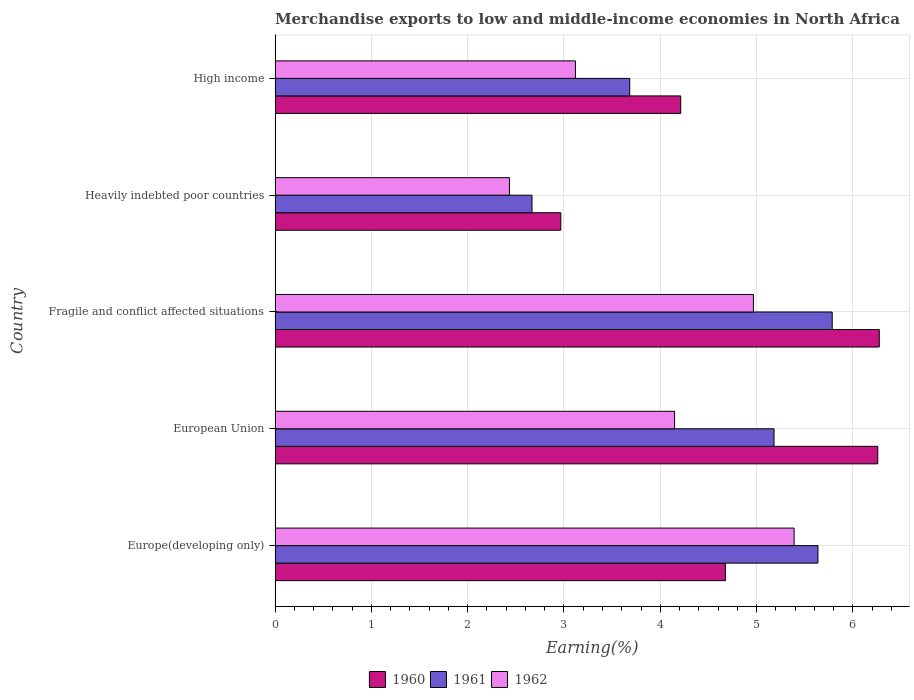How many different coloured bars are there?
Offer a terse response. 3. How many groups of bars are there?
Give a very brief answer. 5. Are the number of bars per tick equal to the number of legend labels?
Provide a short and direct response. Yes. Are the number of bars on each tick of the Y-axis equal?
Provide a short and direct response. Yes. How many bars are there on the 4th tick from the top?
Provide a short and direct response. 3. How many bars are there on the 3rd tick from the bottom?
Your answer should be compact. 3. What is the label of the 2nd group of bars from the top?
Provide a succinct answer. Heavily indebted poor countries. In how many cases, is the number of bars for a given country not equal to the number of legend labels?
Your response must be concise. 0. What is the percentage of amount earned from merchandise exports in 1962 in Europe(developing only)?
Make the answer very short. 5.39. Across all countries, what is the maximum percentage of amount earned from merchandise exports in 1961?
Make the answer very short. 5.79. Across all countries, what is the minimum percentage of amount earned from merchandise exports in 1962?
Your answer should be compact. 2.43. In which country was the percentage of amount earned from merchandise exports in 1962 maximum?
Ensure brevity in your answer.  Europe(developing only). In which country was the percentage of amount earned from merchandise exports in 1962 minimum?
Give a very brief answer. Heavily indebted poor countries. What is the total percentage of amount earned from merchandise exports in 1960 in the graph?
Offer a very short reply. 24.39. What is the difference between the percentage of amount earned from merchandise exports in 1962 in European Union and that in Fragile and conflict affected situations?
Provide a short and direct response. -0.82. What is the difference between the percentage of amount earned from merchandise exports in 1961 in Heavily indebted poor countries and the percentage of amount earned from merchandise exports in 1960 in European Union?
Offer a very short reply. -3.59. What is the average percentage of amount earned from merchandise exports in 1961 per country?
Keep it short and to the point. 4.59. What is the difference between the percentage of amount earned from merchandise exports in 1961 and percentage of amount earned from merchandise exports in 1962 in Fragile and conflict affected situations?
Provide a short and direct response. 0.82. In how many countries, is the percentage of amount earned from merchandise exports in 1962 greater than 1.8 %?
Your response must be concise. 5. What is the ratio of the percentage of amount earned from merchandise exports in 1961 in Europe(developing only) to that in High income?
Your answer should be very brief. 1.53. Is the percentage of amount earned from merchandise exports in 1961 in Fragile and conflict affected situations less than that in High income?
Your answer should be very brief. No. Is the difference between the percentage of amount earned from merchandise exports in 1961 in Europe(developing only) and Fragile and conflict affected situations greater than the difference between the percentage of amount earned from merchandise exports in 1962 in Europe(developing only) and Fragile and conflict affected situations?
Keep it short and to the point. No. What is the difference between the highest and the second highest percentage of amount earned from merchandise exports in 1961?
Give a very brief answer. 0.15. What is the difference between the highest and the lowest percentage of amount earned from merchandise exports in 1960?
Provide a short and direct response. 3.31. In how many countries, is the percentage of amount earned from merchandise exports in 1960 greater than the average percentage of amount earned from merchandise exports in 1960 taken over all countries?
Your answer should be very brief. 2. What does the 1st bar from the bottom in Europe(developing only) represents?
Your answer should be compact. 1960. Is it the case that in every country, the sum of the percentage of amount earned from merchandise exports in 1962 and percentage of amount earned from merchandise exports in 1960 is greater than the percentage of amount earned from merchandise exports in 1961?
Your answer should be compact. Yes. Are the values on the major ticks of X-axis written in scientific E-notation?
Keep it short and to the point. No. Does the graph contain grids?
Your answer should be very brief. Yes. Where does the legend appear in the graph?
Your response must be concise. Bottom center. How many legend labels are there?
Keep it short and to the point. 3. How are the legend labels stacked?
Provide a short and direct response. Horizontal. What is the title of the graph?
Ensure brevity in your answer.  Merchandise exports to low and middle-income economies in North Africa. Does "1966" appear as one of the legend labels in the graph?
Provide a short and direct response. No. What is the label or title of the X-axis?
Provide a short and direct response. Earning(%). What is the Earning(%) of 1960 in Europe(developing only)?
Ensure brevity in your answer.  4.68. What is the Earning(%) of 1961 in Europe(developing only)?
Provide a short and direct response. 5.64. What is the Earning(%) in 1962 in Europe(developing only)?
Your answer should be very brief. 5.39. What is the Earning(%) in 1960 in European Union?
Provide a short and direct response. 6.26. What is the Earning(%) of 1961 in European Union?
Your answer should be very brief. 5.18. What is the Earning(%) of 1962 in European Union?
Keep it short and to the point. 4.15. What is the Earning(%) of 1960 in Fragile and conflict affected situations?
Provide a succinct answer. 6.27. What is the Earning(%) of 1961 in Fragile and conflict affected situations?
Offer a very short reply. 5.79. What is the Earning(%) of 1962 in Fragile and conflict affected situations?
Give a very brief answer. 4.97. What is the Earning(%) in 1960 in Heavily indebted poor countries?
Your answer should be compact. 2.97. What is the Earning(%) of 1961 in Heavily indebted poor countries?
Your answer should be compact. 2.67. What is the Earning(%) in 1962 in Heavily indebted poor countries?
Offer a very short reply. 2.43. What is the Earning(%) of 1960 in High income?
Your answer should be compact. 4.21. What is the Earning(%) in 1961 in High income?
Give a very brief answer. 3.68. What is the Earning(%) in 1962 in High income?
Make the answer very short. 3.12. Across all countries, what is the maximum Earning(%) of 1960?
Keep it short and to the point. 6.27. Across all countries, what is the maximum Earning(%) of 1961?
Your answer should be very brief. 5.79. Across all countries, what is the maximum Earning(%) in 1962?
Provide a short and direct response. 5.39. Across all countries, what is the minimum Earning(%) of 1960?
Provide a succinct answer. 2.97. Across all countries, what is the minimum Earning(%) of 1961?
Offer a very short reply. 2.67. Across all countries, what is the minimum Earning(%) of 1962?
Keep it short and to the point. 2.43. What is the total Earning(%) in 1960 in the graph?
Offer a terse response. 24.39. What is the total Earning(%) of 1961 in the graph?
Make the answer very short. 22.95. What is the total Earning(%) of 1962 in the graph?
Ensure brevity in your answer.  20.06. What is the difference between the Earning(%) of 1960 in Europe(developing only) and that in European Union?
Your answer should be very brief. -1.58. What is the difference between the Earning(%) in 1961 in Europe(developing only) and that in European Union?
Your answer should be very brief. 0.46. What is the difference between the Earning(%) of 1962 in Europe(developing only) and that in European Union?
Ensure brevity in your answer.  1.24. What is the difference between the Earning(%) in 1960 in Europe(developing only) and that in Fragile and conflict affected situations?
Make the answer very short. -1.6. What is the difference between the Earning(%) in 1961 in Europe(developing only) and that in Fragile and conflict affected situations?
Ensure brevity in your answer.  -0.15. What is the difference between the Earning(%) in 1962 in Europe(developing only) and that in Fragile and conflict affected situations?
Give a very brief answer. 0.42. What is the difference between the Earning(%) in 1960 in Europe(developing only) and that in Heavily indebted poor countries?
Your answer should be very brief. 1.71. What is the difference between the Earning(%) of 1961 in Europe(developing only) and that in Heavily indebted poor countries?
Provide a succinct answer. 2.97. What is the difference between the Earning(%) in 1962 in Europe(developing only) and that in Heavily indebted poor countries?
Keep it short and to the point. 2.96. What is the difference between the Earning(%) in 1960 in Europe(developing only) and that in High income?
Your response must be concise. 0.46. What is the difference between the Earning(%) of 1961 in Europe(developing only) and that in High income?
Make the answer very short. 1.95. What is the difference between the Earning(%) of 1962 in Europe(developing only) and that in High income?
Ensure brevity in your answer.  2.27. What is the difference between the Earning(%) of 1960 in European Union and that in Fragile and conflict affected situations?
Your response must be concise. -0.02. What is the difference between the Earning(%) in 1961 in European Union and that in Fragile and conflict affected situations?
Give a very brief answer. -0.6. What is the difference between the Earning(%) of 1962 in European Union and that in Fragile and conflict affected situations?
Ensure brevity in your answer.  -0.82. What is the difference between the Earning(%) in 1960 in European Union and that in Heavily indebted poor countries?
Provide a succinct answer. 3.29. What is the difference between the Earning(%) of 1961 in European Union and that in Heavily indebted poor countries?
Provide a short and direct response. 2.51. What is the difference between the Earning(%) of 1962 in European Union and that in Heavily indebted poor countries?
Provide a succinct answer. 1.71. What is the difference between the Earning(%) in 1960 in European Union and that in High income?
Give a very brief answer. 2.05. What is the difference between the Earning(%) of 1961 in European Union and that in High income?
Make the answer very short. 1.5. What is the difference between the Earning(%) of 1962 in European Union and that in High income?
Provide a short and direct response. 1.03. What is the difference between the Earning(%) in 1960 in Fragile and conflict affected situations and that in Heavily indebted poor countries?
Offer a very short reply. 3.31. What is the difference between the Earning(%) in 1961 in Fragile and conflict affected situations and that in Heavily indebted poor countries?
Your answer should be very brief. 3.12. What is the difference between the Earning(%) of 1962 in Fragile and conflict affected situations and that in Heavily indebted poor countries?
Your answer should be compact. 2.53. What is the difference between the Earning(%) of 1960 in Fragile and conflict affected situations and that in High income?
Ensure brevity in your answer.  2.06. What is the difference between the Earning(%) in 1961 in Fragile and conflict affected situations and that in High income?
Provide a succinct answer. 2.1. What is the difference between the Earning(%) in 1962 in Fragile and conflict affected situations and that in High income?
Provide a short and direct response. 1.85. What is the difference between the Earning(%) of 1960 in Heavily indebted poor countries and that in High income?
Provide a succinct answer. -1.25. What is the difference between the Earning(%) in 1961 in Heavily indebted poor countries and that in High income?
Offer a terse response. -1.01. What is the difference between the Earning(%) of 1962 in Heavily indebted poor countries and that in High income?
Give a very brief answer. -0.69. What is the difference between the Earning(%) of 1960 in Europe(developing only) and the Earning(%) of 1961 in European Union?
Offer a very short reply. -0.5. What is the difference between the Earning(%) of 1960 in Europe(developing only) and the Earning(%) of 1962 in European Union?
Your answer should be very brief. 0.53. What is the difference between the Earning(%) of 1961 in Europe(developing only) and the Earning(%) of 1962 in European Union?
Offer a terse response. 1.49. What is the difference between the Earning(%) in 1960 in Europe(developing only) and the Earning(%) in 1961 in Fragile and conflict affected situations?
Your response must be concise. -1.11. What is the difference between the Earning(%) in 1960 in Europe(developing only) and the Earning(%) in 1962 in Fragile and conflict affected situations?
Give a very brief answer. -0.29. What is the difference between the Earning(%) of 1961 in Europe(developing only) and the Earning(%) of 1962 in Fragile and conflict affected situations?
Give a very brief answer. 0.67. What is the difference between the Earning(%) of 1960 in Europe(developing only) and the Earning(%) of 1961 in Heavily indebted poor countries?
Your answer should be compact. 2.01. What is the difference between the Earning(%) of 1960 in Europe(developing only) and the Earning(%) of 1962 in Heavily indebted poor countries?
Offer a terse response. 2.24. What is the difference between the Earning(%) in 1961 in Europe(developing only) and the Earning(%) in 1962 in Heavily indebted poor countries?
Provide a succinct answer. 3.2. What is the difference between the Earning(%) in 1960 in Europe(developing only) and the Earning(%) in 1962 in High income?
Ensure brevity in your answer.  1.56. What is the difference between the Earning(%) in 1961 in Europe(developing only) and the Earning(%) in 1962 in High income?
Your response must be concise. 2.52. What is the difference between the Earning(%) of 1960 in European Union and the Earning(%) of 1961 in Fragile and conflict affected situations?
Ensure brevity in your answer.  0.47. What is the difference between the Earning(%) of 1960 in European Union and the Earning(%) of 1962 in Fragile and conflict affected situations?
Keep it short and to the point. 1.29. What is the difference between the Earning(%) of 1961 in European Union and the Earning(%) of 1962 in Fragile and conflict affected situations?
Keep it short and to the point. 0.21. What is the difference between the Earning(%) of 1960 in European Union and the Earning(%) of 1961 in Heavily indebted poor countries?
Offer a very short reply. 3.59. What is the difference between the Earning(%) in 1960 in European Union and the Earning(%) in 1962 in Heavily indebted poor countries?
Give a very brief answer. 3.82. What is the difference between the Earning(%) of 1961 in European Union and the Earning(%) of 1962 in Heavily indebted poor countries?
Your response must be concise. 2.75. What is the difference between the Earning(%) in 1960 in European Union and the Earning(%) in 1961 in High income?
Ensure brevity in your answer.  2.58. What is the difference between the Earning(%) of 1960 in European Union and the Earning(%) of 1962 in High income?
Your answer should be compact. 3.14. What is the difference between the Earning(%) in 1961 in European Union and the Earning(%) in 1962 in High income?
Your answer should be very brief. 2.06. What is the difference between the Earning(%) of 1960 in Fragile and conflict affected situations and the Earning(%) of 1961 in Heavily indebted poor countries?
Offer a terse response. 3.61. What is the difference between the Earning(%) in 1960 in Fragile and conflict affected situations and the Earning(%) in 1962 in Heavily indebted poor countries?
Offer a terse response. 3.84. What is the difference between the Earning(%) of 1961 in Fragile and conflict affected situations and the Earning(%) of 1962 in Heavily indebted poor countries?
Offer a terse response. 3.35. What is the difference between the Earning(%) in 1960 in Fragile and conflict affected situations and the Earning(%) in 1961 in High income?
Provide a succinct answer. 2.59. What is the difference between the Earning(%) in 1960 in Fragile and conflict affected situations and the Earning(%) in 1962 in High income?
Give a very brief answer. 3.15. What is the difference between the Earning(%) of 1961 in Fragile and conflict affected situations and the Earning(%) of 1962 in High income?
Offer a terse response. 2.67. What is the difference between the Earning(%) of 1960 in Heavily indebted poor countries and the Earning(%) of 1961 in High income?
Provide a short and direct response. -0.72. What is the difference between the Earning(%) in 1960 in Heavily indebted poor countries and the Earning(%) in 1962 in High income?
Your answer should be very brief. -0.15. What is the difference between the Earning(%) in 1961 in Heavily indebted poor countries and the Earning(%) in 1962 in High income?
Ensure brevity in your answer.  -0.45. What is the average Earning(%) of 1960 per country?
Ensure brevity in your answer.  4.88. What is the average Earning(%) of 1961 per country?
Offer a terse response. 4.59. What is the average Earning(%) of 1962 per country?
Provide a succinct answer. 4.01. What is the difference between the Earning(%) in 1960 and Earning(%) in 1961 in Europe(developing only)?
Keep it short and to the point. -0.96. What is the difference between the Earning(%) in 1960 and Earning(%) in 1962 in Europe(developing only)?
Your answer should be compact. -0.71. What is the difference between the Earning(%) in 1961 and Earning(%) in 1962 in Europe(developing only)?
Your response must be concise. 0.25. What is the difference between the Earning(%) in 1960 and Earning(%) in 1961 in European Union?
Your answer should be very brief. 1.08. What is the difference between the Earning(%) of 1960 and Earning(%) of 1962 in European Union?
Offer a terse response. 2.11. What is the difference between the Earning(%) of 1961 and Earning(%) of 1962 in European Union?
Your answer should be very brief. 1.03. What is the difference between the Earning(%) of 1960 and Earning(%) of 1961 in Fragile and conflict affected situations?
Provide a short and direct response. 0.49. What is the difference between the Earning(%) in 1960 and Earning(%) in 1962 in Fragile and conflict affected situations?
Offer a terse response. 1.31. What is the difference between the Earning(%) in 1961 and Earning(%) in 1962 in Fragile and conflict affected situations?
Your response must be concise. 0.82. What is the difference between the Earning(%) of 1960 and Earning(%) of 1961 in Heavily indebted poor countries?
Make the answer very short. 0.3. What is the difference between the Earning(%) of 1960 and Earning(%) of 1962 in Heavily indebted poor countries?
Give a very brief answer. 0.53. What is the difference between the Earning(%) in 1961 and Earning(%) in 1962 in Heavily indebted poor countries?
Provide a succinct answer. 0.23. What is the difference between the Earning(%) in 1960 and Earning(%) in 1961 in High income?
Ensure brevity in your answer.  0.53. What is the difference between the Earning(%) in 1960 and Earning(%) in 1962 in High income?
Provide a short and direct response. 1.09. What is the difference between the Earning(%) in 1961 and Earning(%) in 1962 in High income?
Your answer should be compact. 0.56. What is the ratio of the Earning(%) of 1960 in Europe(developing only) to that in European Union?
Your answer should be compact. 0.75. What is the ratio of the Earning(%) in 1961 in Europe(developing only) to that in European Union?
Your answer should be compact. 1.09. What is the ratio of the Earning(%) in 1962 in Europe(developing only) to that in European Union?
Give a very brief answer. 1.3. What is the ratio of the Earning(%) in 1960 in Europe(developing only) to that in Fragile and conflict affected situations?
Offer a terse response. 0.75. What is the ratio of the Earning(%) in 1961 in Europe(developing only) to that in Fragile and conflict affected situations?
Provide a short and direct response. 0.97. What is the ratio of the Earning(%) in 1962 in Europe(developing only) to that in Fragile and conflict affected situations?
Your answer should be compact. 1.08. What is the ratio of the Earning(%) in 1960 in Europe(developing only) to that in Heavily indebted poor countries?
Keep it short and to the point. 1.58. What is the ratio of the Earning(%) of 1961 in Europe(developing only) to that in Heavily indebted poor countries?
Offer a very short reply. 2.11. What is the ratio of the Earning(%) of 1962 in Europe(developing only) to that in Heavily indebted poor countries?
Give a very brief answer. 2.21. What is the ratio of the Earning(%) in 1960 in Europe(developing only) to that in High income?
Offer a terse response. 1.11. What is the ratio of the Earning(%) in 1961 in Europe(developing only) to that in High income?
Make the answer very short. 1.53. What is the ratio of the Earning(%) in 1962 in Europe(developing only) to that in High income?
Your answer should be compact. 1.73. What is the ratio of the Earning(%) of 1960 in European Union to that in Fragile and conflict affected situations?
Your response must be concise. 1. What is the ratio of the Earning(%) in 1961 in European Union to that in Fragile and conflict affected situations?
Keep it short and to the point. 0.9. What is the ratio of the Earning(%) in 1962 in European Union to that in Fragile and conflict affected situations?
Ensure brevity in your answer.  0.84. What is the ratio of the Earning(%) in 1960 in European Union to that in Heavily indebted poor countries?
Give a very brief answer. 2.11. What is the ratio of the Earning(%) of 1961 in European Union to that in Heavily indebted poor countries?
Give a very brief answer. 1.94. What is the ratio of the Earning(%) in 1962 in European Union to that in Heavily indebted poor countries?
Offer a terse response. 1.7. What is the ratio of the Earning(%) in 1960 in European Union to that in High income?
Your response must be concise. 1.49. What is the ratio of the Earning(%) in 1961 in European Union to that in High income?
Ensure brevity in your answer.  1.41. What is the ratio of the Earning(%) of 1962 in European Union to that in High income?
Keep it short and to the point. 1.33. What is the ratio of the Earning(%) in 1960 in Fragile and conflict affected situations to that in Heavily indebted poor countries?
Provide a short and direct response. 2.11. What is the ratio of the Earning(%) in 1961 in Fragile and conflict affected situations to that in Heavily indebted poor countries?
Give a very brief answer. 2.17. What is the ratio of the Earning(%) of 1962 in Fragile and conflict affected situations to that in Heavily indebted poor countries?
Make the answer very short. 2.04. What is the ratio of the Earning(%) of 1960 in Fragile and conflict affected situations to that in High income?
Make the answer very short. 1.49. What is the ratio of the Earning(%) in 1961 in Fragile and conflict affected situations to that in High income?
Your answer should be compact. 1.57. What is the ratio of the Earning(%) of 1962 in Fragile and conflict affected situations to that in High income?
Offer a terse response. 1.59. What is the ratio of the Earning(%) of 1960 in Heavily indebted poor countries to that in High income?
Offer a terse response. 0.7. What is the ratio of the Earning(%) of 1961 in Heavily indebted poor countries to that in High income?
Offer a terse response. 0.72. What is the ratio of the Earning(%) of 1962 in Heavily indebted poor countries to that in High income?
Keep it short and to the point. 0.78. What is the difference between the highest and the second highest Earning(%) of 1960?
Provide a short and direct response. 0.02. What is the difference between the highest and the second highest Earning(%) in 1961?
Give a very brief answer. 0.15. What is the difference between the highest and the second highest Earning(%) of 1962?
Provide a succinct answer. 0.42. What is the difference between the highest and the lowest Earning(%) of 1960?
Give a very brief answer. 3.31. What is the difference between the highest and the lowest Earning(%) in 1961?
Your response must be concise. 3.12. What is the difference between the highest and the lowest Earning(%) in 1962?
Your response must be concise. 2.96. 